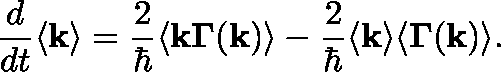<formula> <loc_0><loc_0><loc_500><loc_500>\frac { d } { d t } \langle k \rangle = \frac { 2 } { } \langle k \Gamma ( k ) \rangle - \frac { 2 } { } \langle k \rangle \langle \Gamma ( k ) \rangle .</formula> 